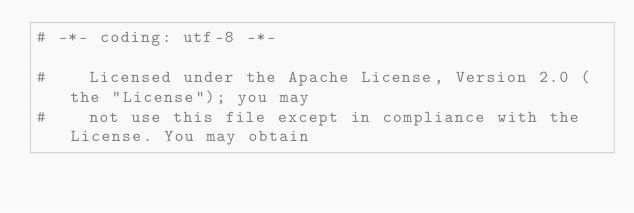<code> <loc_0><loc_0><loc_500><loc_500><_Python_># -*- coding: utf-8 -*-

#    Licensed under the Apache License, Version 2.0 (the "License"); you may
#    not use this file except in compliance with the License. You may obtain</code> 